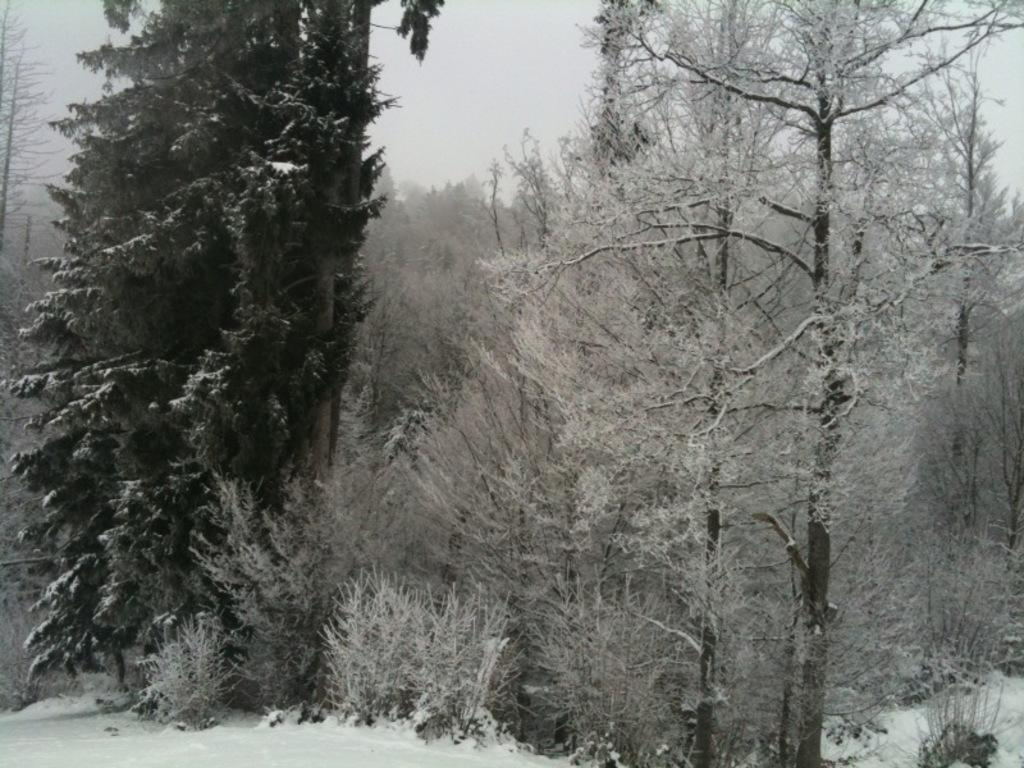What is the color scheme of the image? The image is black and white. What type of vegetation can be seen in the image? There are trees in the image. What is covering the ground in the image? There is snow on the ground in the image. What can be seen in the background of the image? The sky is visible in the background of the image. What type of meal is being prepared in the image? There is no meal preparation visible in the image; it is a black and white image featuring trees, snow, and the sky. 